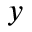<formula> <loc_0><loc_0><loc_500><loc_500>y</formula> 